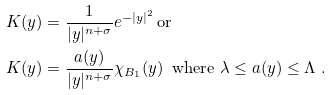<formula> <loc_0><loc_0><loc_500><loc_500>K ( y ) & = \frac { 1 } { | y | ^ { n + \sigma } } e ^ { - | y | ^ { 2 } } \, \text {or} \\ K ( y ) & = \frac { a ( y ) } { | y | ^ { n + \sigma } } \chi _ { B _ { 1 } } ( y ) \, \text { where } \lambda \leq a ( y ) \leq \Lambda \ . \\</formula> 